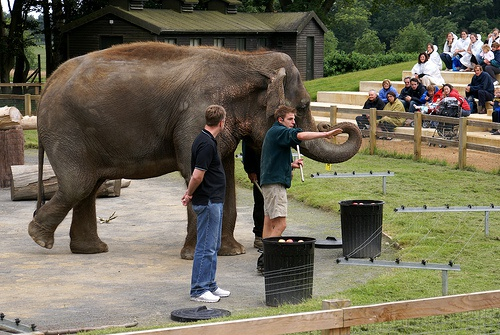Describe the objects in this image and their specific colors. I can see elephant in black, gray, and maroon tones, people in black, darkblue, and gray tones, people in black, gray, and darkgray tones, people in black, white, gray, and darkgray tones, and people in black, navy, brown, and gray tones in this image. 